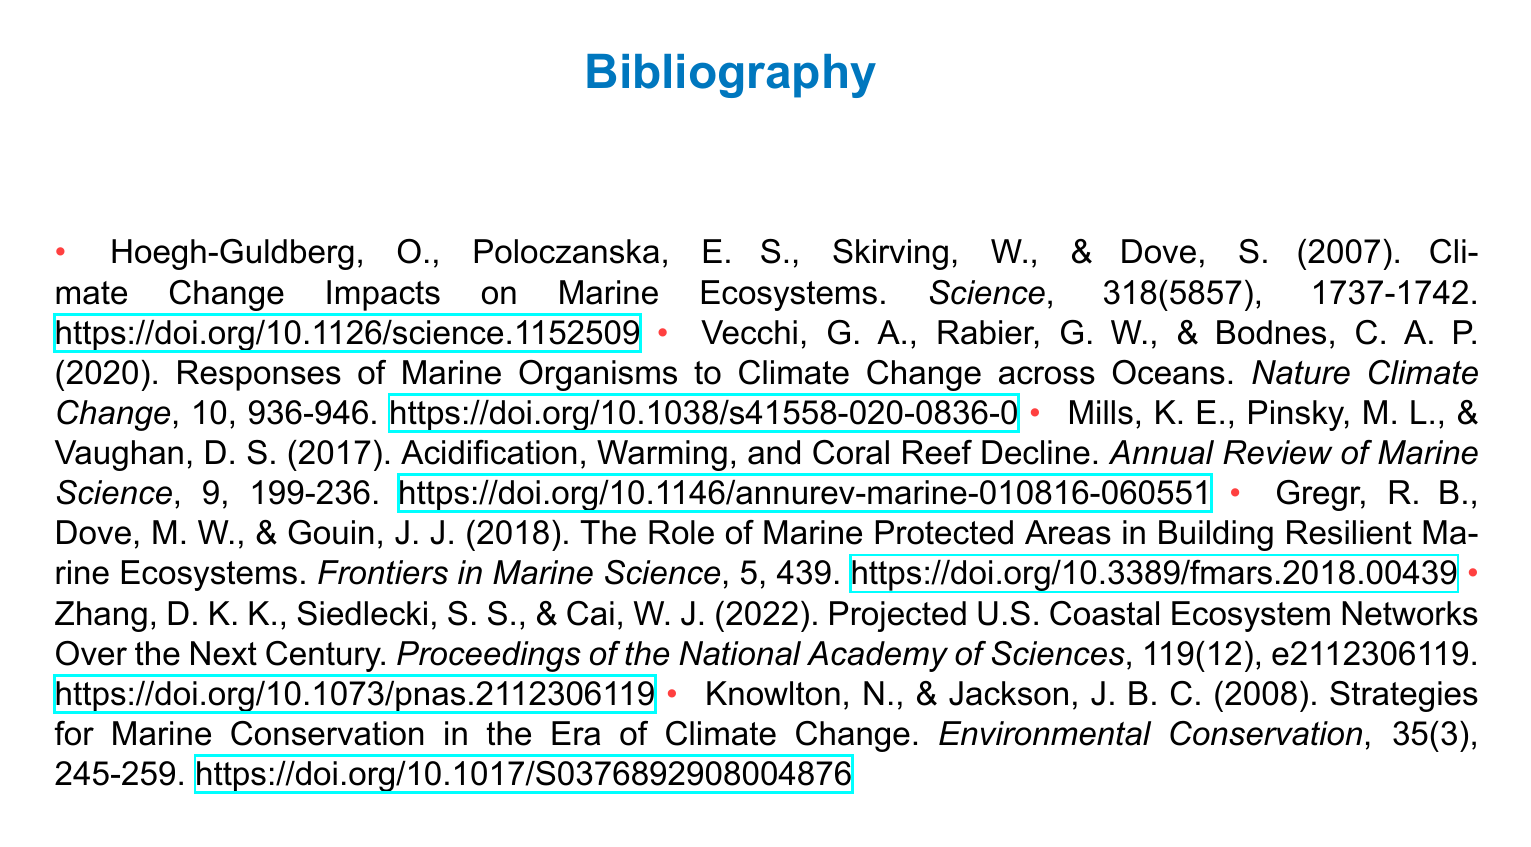What is the title of the first cited paper? The title of the first cited paper is found in the citation of Hoegh-Guldberg et al. (2007) and is "Climate Change Impacts on Marine Ecosystems."
Answer: Climate Change Impacts on Marine Ecosystems How many authors contributed to the paper by Knowlton and Jackson? The paper by Knowlton and Jackson (2008) has two authors as listed in the citation.
Answer: 2 What is the main focus area of the study by Zhang et al. (2022)? The main focus area of the study by Zhang et al. (2022) is indicated in the citation, which looks at projected ecosystems.
Answer: Projected U.S. Coastal Ecosystem Networks In what year was the publication by Mills et al. released? The publication by Mills et al. is dated 2017, as noted in its citation.
Answer: 2017 What journal was the paper by Gregr et al. published in? The paper by Gregr et al. (2018) was published in "Frontiers in Marine Science."
Answer: Frontiers in Marine Science Which publication discusses marine conservation strategies? The publication that discusses marine conservation strategies is indicated by Knowlton and Jackson (2008).
Answer: Strategies for Marine Conservation in the Era of Climate Change How many citations are provided in the bibliography? The bibliography lists six citations in total, corresponding to the six papers cited.
Answer: 6 What is the DOI link format used in the document? The DOI link format in the document includes the prefix followed by the unique identifier, which is consistent across different citations.
Answer: https://doi.org/{identifier} What type of document is this? The document is a bibliography, which lists references used for scientific papers.
Answer: Bibliography 